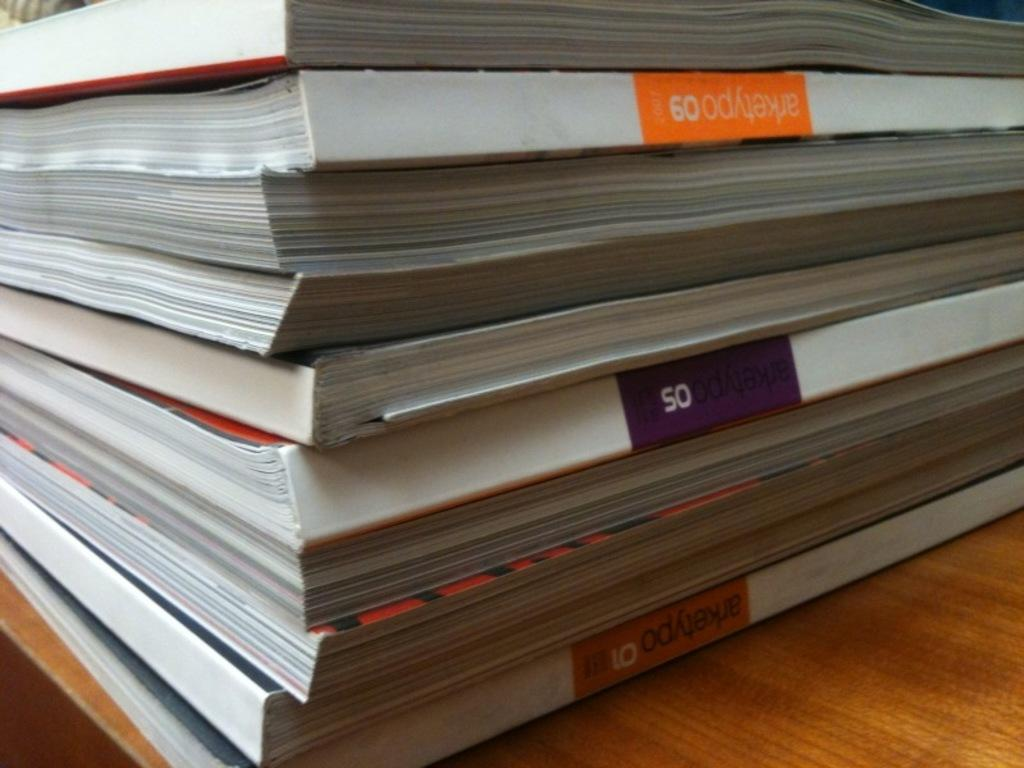<image>
Create a compact narrative representing the image presented. A book about arketypo 09 sits with several other books in a stack. 